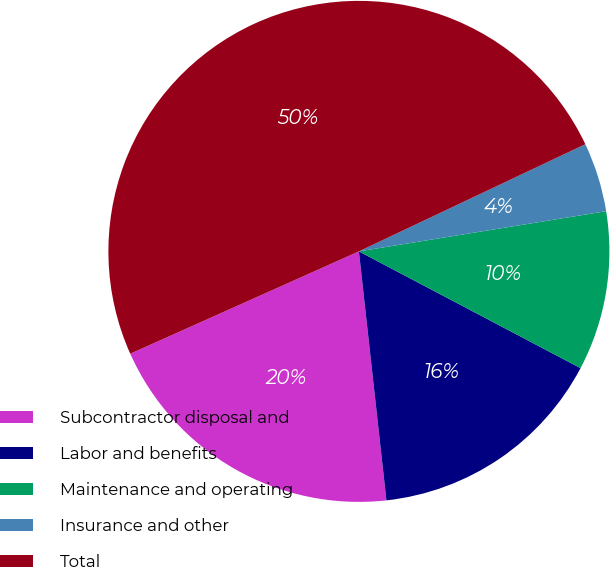<chart> <loc_0><loc_0><loc_500><loc_500><pie_chart><fcel>Subcontractor disposal and<fcel>Labor and benefits<fcel>Maintenance and operating<fcel>Insurance and other<fcel>Total<nl><fcel>20.05%<fcel>15.53%<fcel>10.28%<fcel>4.47%<fcel>49.66%<nl></chart> 